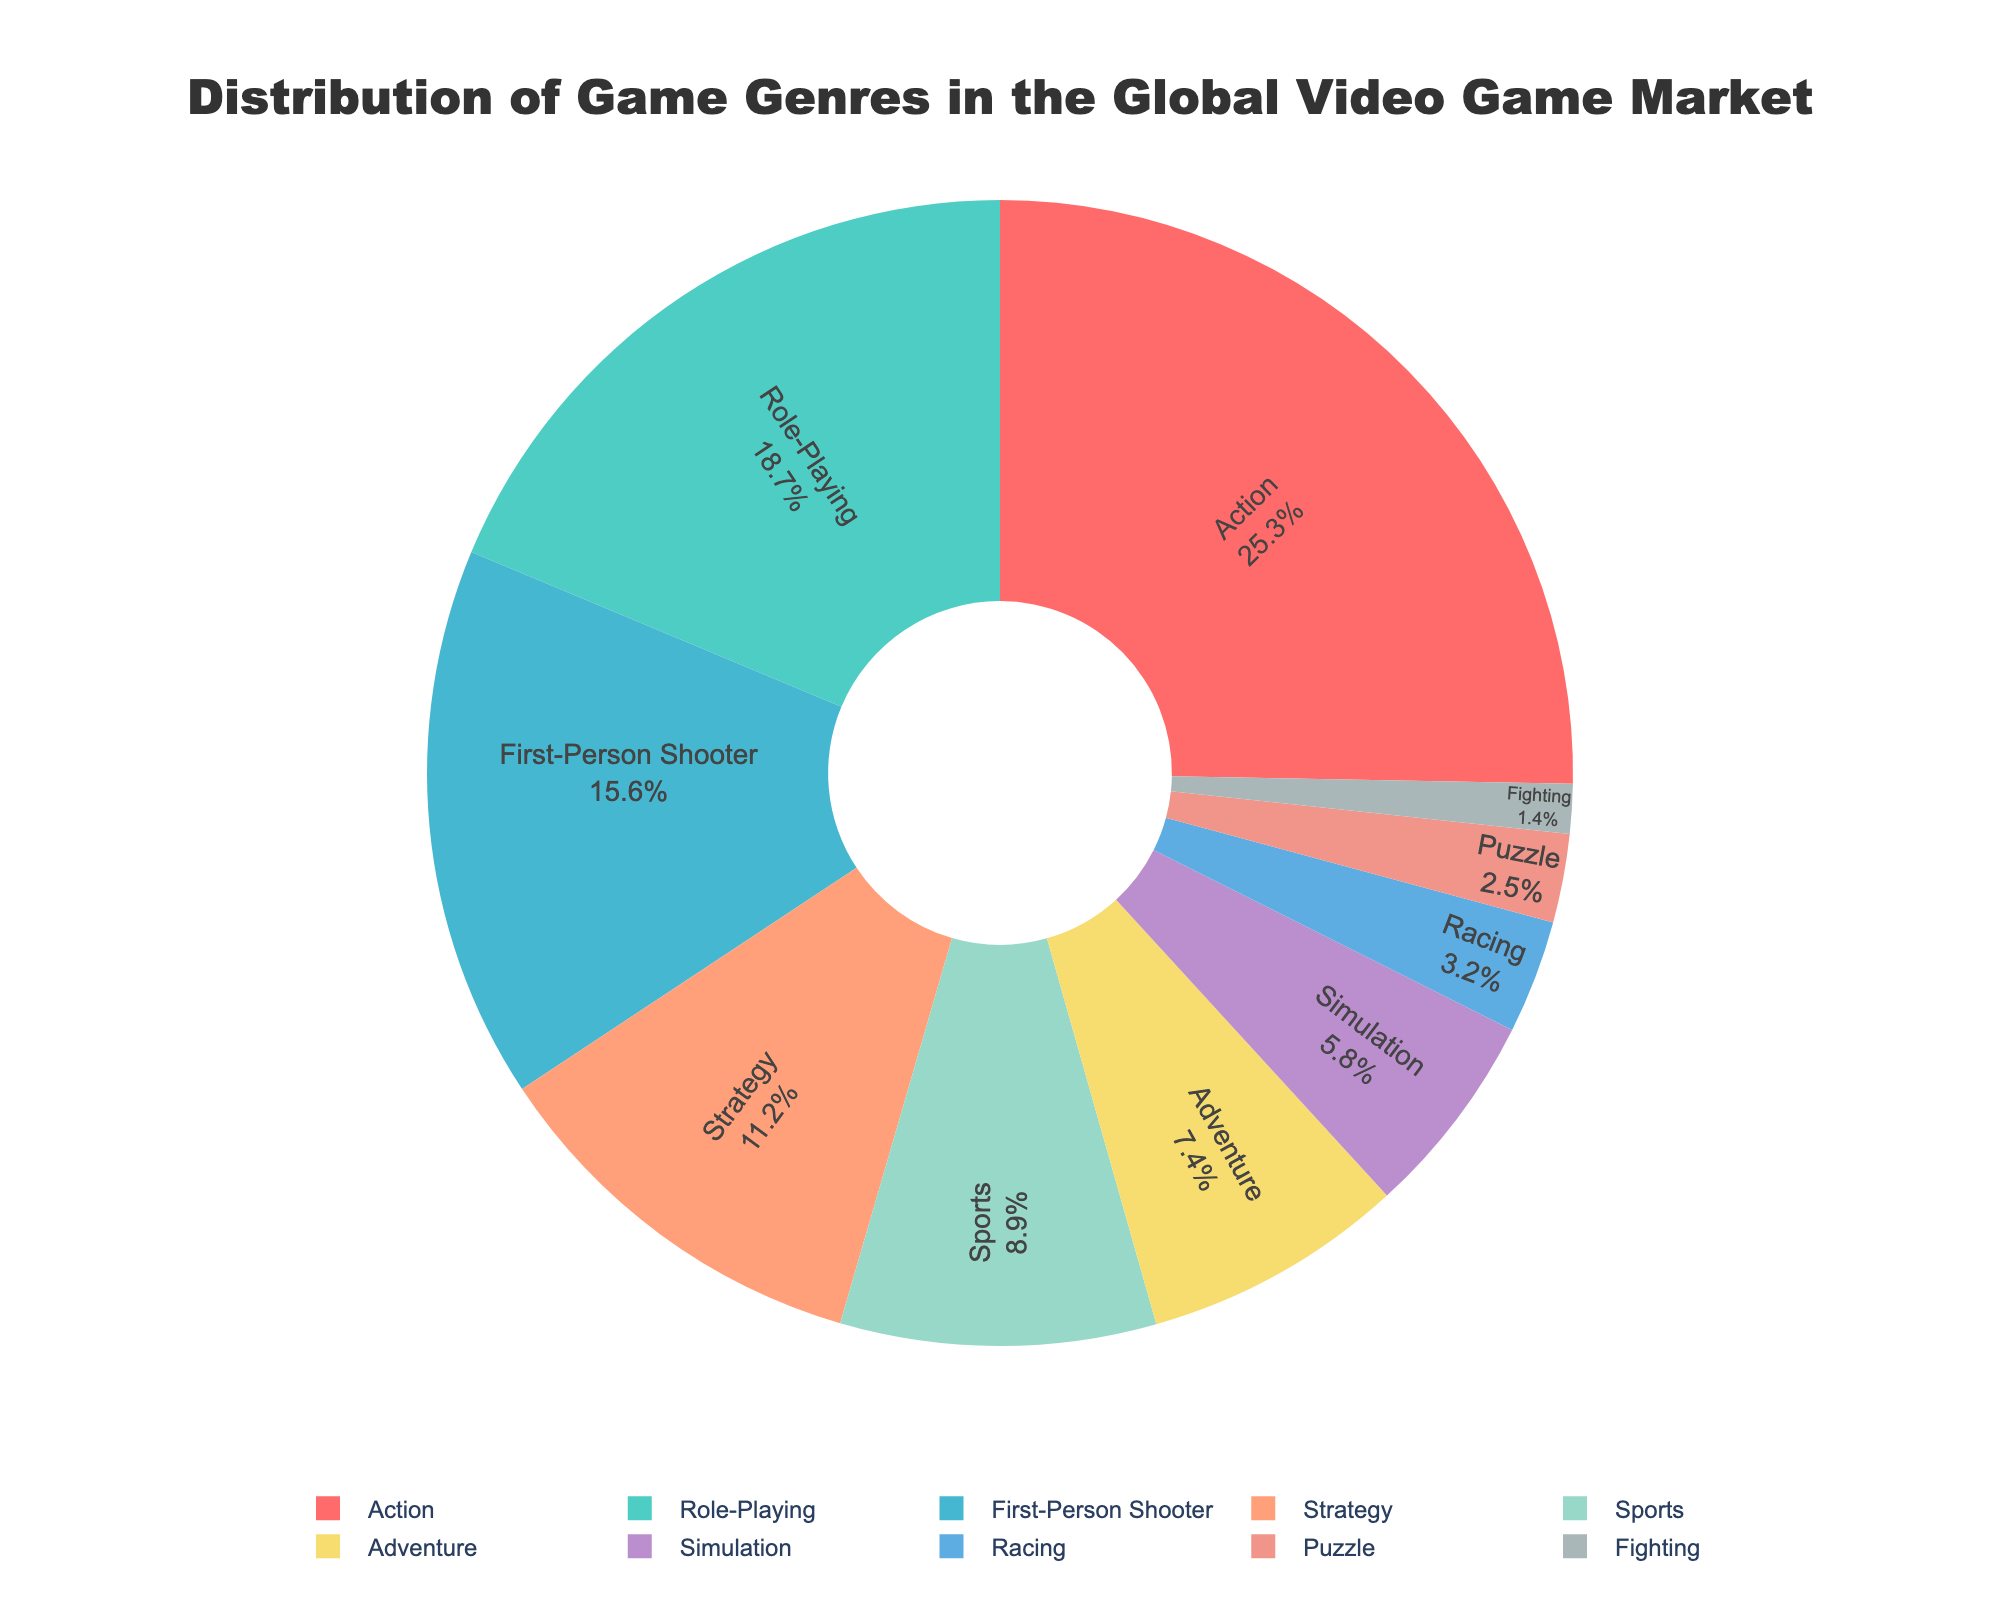What is the percentage share of Action games? The pie chart indicates that Action games make up 25.3% of the global video game market.
Answer: 25.3% Which genre has the smallest market share? From the pie chart, it is seen that Fighting games have the smallest market share at 1.4%.
Answer: Fighting What is the combined market share of Role-Playing and Strategy games? The market share of Role-Playing games is 18.7% and Strategy games is 11.2%. Adding these together gives us 18.7 + 11.2 = 29.9%.
Answer: 29.9% Which is more popular: Sports or Adventure games, and by how much? Sports games have an 8.9% market share, whereas Adventure games have a 7.4% share. Subtracting these values, we get 8.9 - 7.4 = 1.5%. So, Sports games are more popular by 1.5%.
Answer: Sports, by 1.5% How does the market share of First-Person Shooter games compare to Racing games? The market share of First-Person Shooter games is 15.6%, while Racing games have a 3.2% share. First-Person Shooter games have a higher market share (15.6%) compared to Racing games (3.2%).
Answer: First-Person Shooter What is the total percentage of market share for genres with a market share above 10%? The genres with a market share above 10% are Action (25.3%), Role-Playing (18.7%), First-Person Shooter (15.6%), and Strategy (11.2%). Adding these together, we get 25.3 + 18.7 + 15.6 + 11.2 = 70.8%.
Answer: 70.8% Which genre has a market share closer to 5%: Simulation or Puzzle games? Simulation games have a market share of 5.8% and Puzzle games have a 2.5% share. Simulation is closer to 5% because the difference is 0.8% compared to Puzzle's difference of 2.5%.
Answer: Simulation What is the difference in market share between the most popular genre and the least popular genre? The most popular genre is Action with 25.3% and the least popular is Fighting with 1.4%. The difference is 25.3 - 1.4 = 23.9%.
Answer: 23.9% How does the market share of Adventure games compare to that of Puzzle and Fighting games combined? The market share of Adventure games is 7.4%. The combined market share of Puzzle (2.5%) and Fighting (1.4%) is 2.5 + 1.4 = 3.9%. Adventure games have a higher market share of 7.4% compared to the combined share of Puzzle and Fighting games (3.9%).
Answer: Adventure What is the difference between the market shares of Simulation and Racing games? The market share of Simulation games is 5.8%, and Racing games have a 3.2% share. The difference is 5.8 - 3.2 = 2.6%.
Answer: 2.6% 